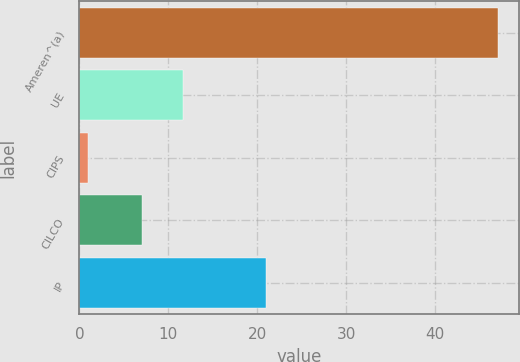<chart> <loc_0><loc_0><loc_500><loc_500><bar_chart><fcel>Ameren^(a)<fcel>UE<fcel>CIPS<fcel>CILCO<fcel>IP<nl><fcel>47<fcel>11.6<fcel>1<fcel>7<fcel>21<nl></chart> 